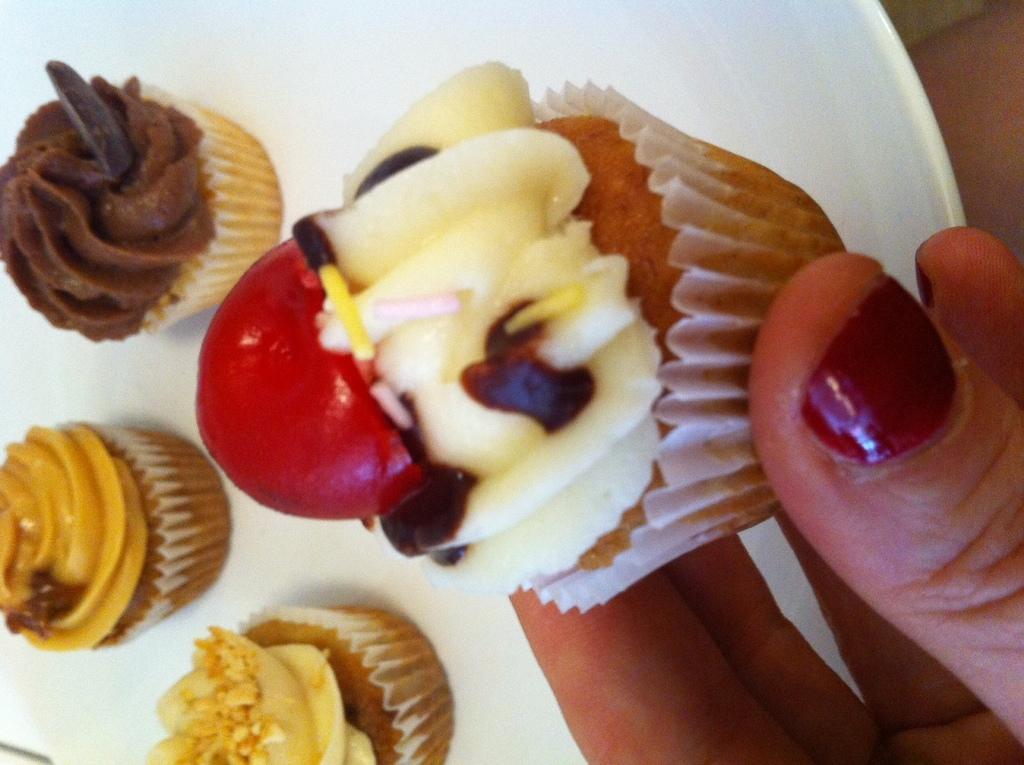Can you describe this image briefly? In this image there is a plate, in that plate there are cupcakes, on the right side there is a hand holding a cup cupcake. 